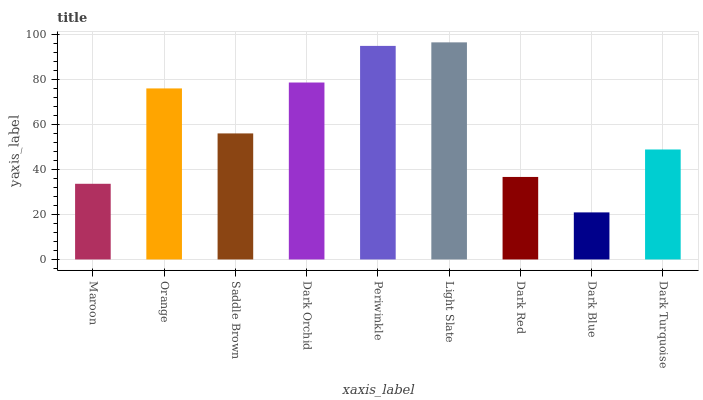Is Dark Blue the minimum?
Answer yes or no. Yes. Is Light Slate the maximum?
Answer yes or no. Yes. Is Orange the minimum?
Answer yes or no. No. Is Orange the maximum?
Answer yes or no. No. Is Orange greater than Maroon?
Answer yes or no. Yes. Is Maroon less than Orange?
Answer yes or no. Yes. Is Maroon greater than Orange?
Answer yes or no. No. Is Orange less than Maroon?
Answer yes or no. No. Is Saddle Brown the high median?
Answer yes or no. Yes. Is Saddle Brown the low median?
Answer yes or no. Yes. Is Dark Blue the high median?
Answer yes or no. No. Is Periwinkle the low median?
Answer yes or no. No. 